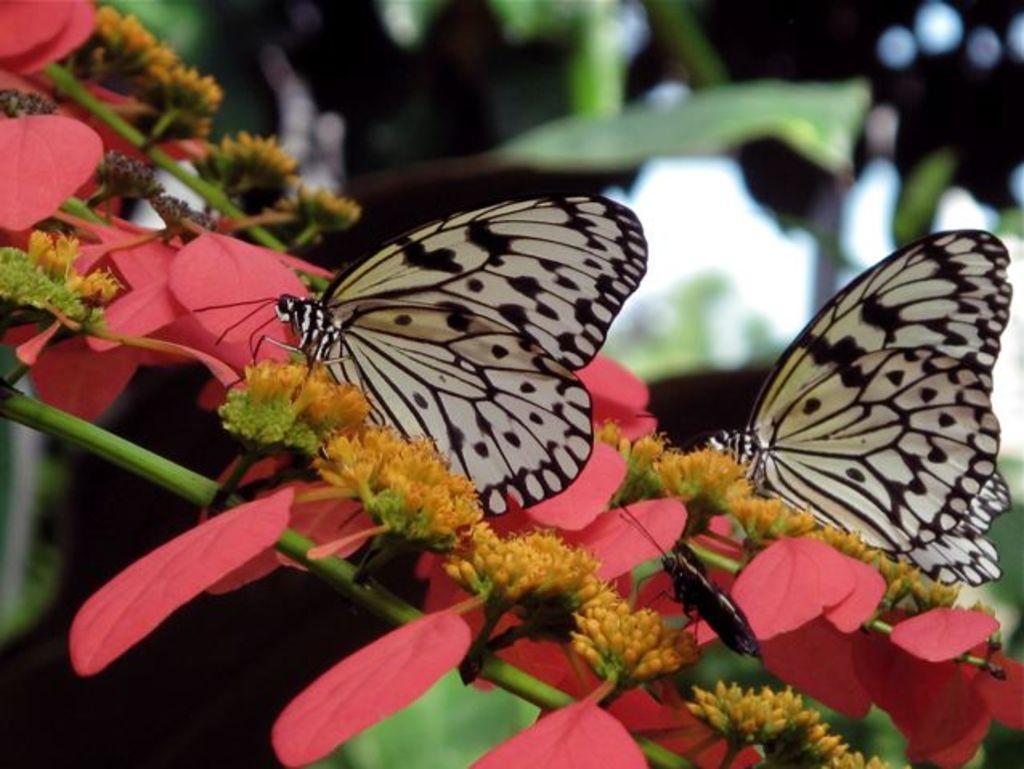In one or two sentences, can you explain what this image depicts? In this image I can see the butterflies and an insect which are in black and white color. These are on the flowers. These are in yellow and pink color. In the back I can see the many plants but it is blurry. 